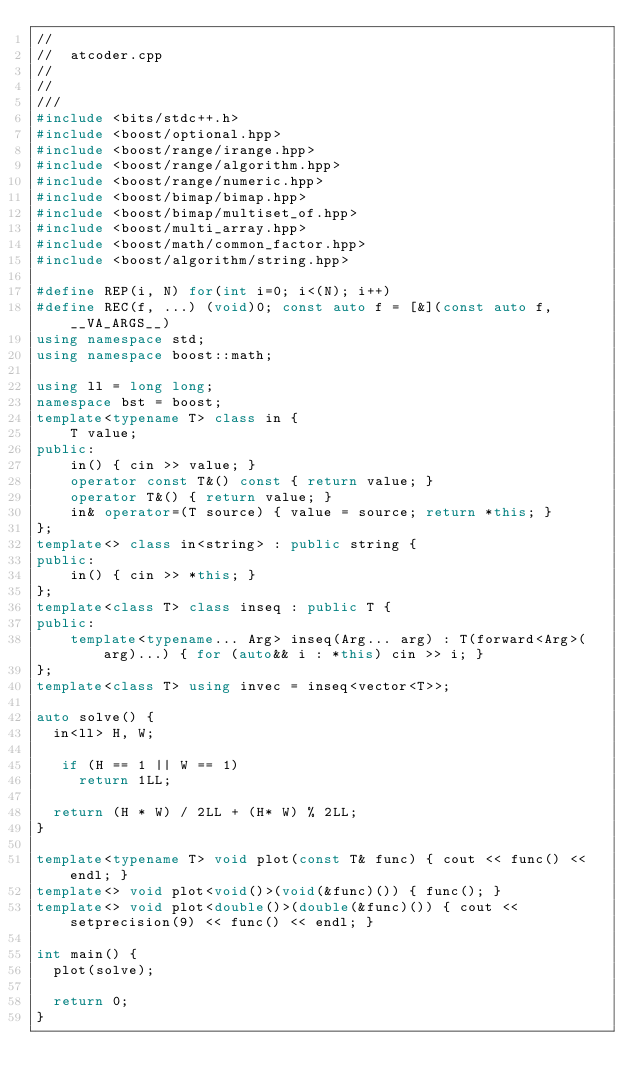Convert code to text. <code><loc_0><loc_0><loc_500><loc_500><_C++_>//
//  atcoder.cpp
//
//
///
#include <bits/stdc++.h>
#include <boost/optional.hpp>
#include <boost/range/irange.hpp>
#include <boost/range/algorithm.hpp>
#include <boost/range/numeric.hpp>
#include <boost/bimap/bimap.hpp>
#include <boost/bimap/multiset_of.hpp>
#include <boost/multi_array.hpp>
#include <boost/math/common_factor.hpp>
#include <boost/algorithm/string.hpp>

#define REP(i, N) for(int i=0; i<(N); i++)
#define REC(f, ...) (void)0; const auto f = [&](const auto f, __VA_ARGS__)
using namespace std;
using namespace boost::math;

using ll = long long;
namespace bst = boost;
template<typename T> class in {
    T value;
public:
    in() { cin >> value; }
    operator const T&() const { return value; }
    operator T&() { return value; }
    in& operator=(T source) { value = source; return *this; }
};
template<> class in<string> : public string {
public:
    in() { cin >> *this; }
};
template<class T> class inseq : public T {
public:
    template<typename... Arg> inseq(Arg... arg) : T(forward<Arg>(arg)...) { for (auto&& i : *this) cin >> i; }
};
template<class T> using invec = inseq<vector<T>>;

auto solve() {
  in<ll> H, W;

   if (H == 1 || W == 1)
     return 1LL;

  return (H * W) / 2LL + (H* W) % 2LL;
}

template<typename T> void plot(const T& func) { cout << func() << endl; }
template<> void plot<void()>(void(&func)()) { func(); }
template<> void plot<double()>(double(&func)()) { cout << setprecision(9) << func() << endl; }

int main() {
  plot(solve);

  return 0;
}


</code> 